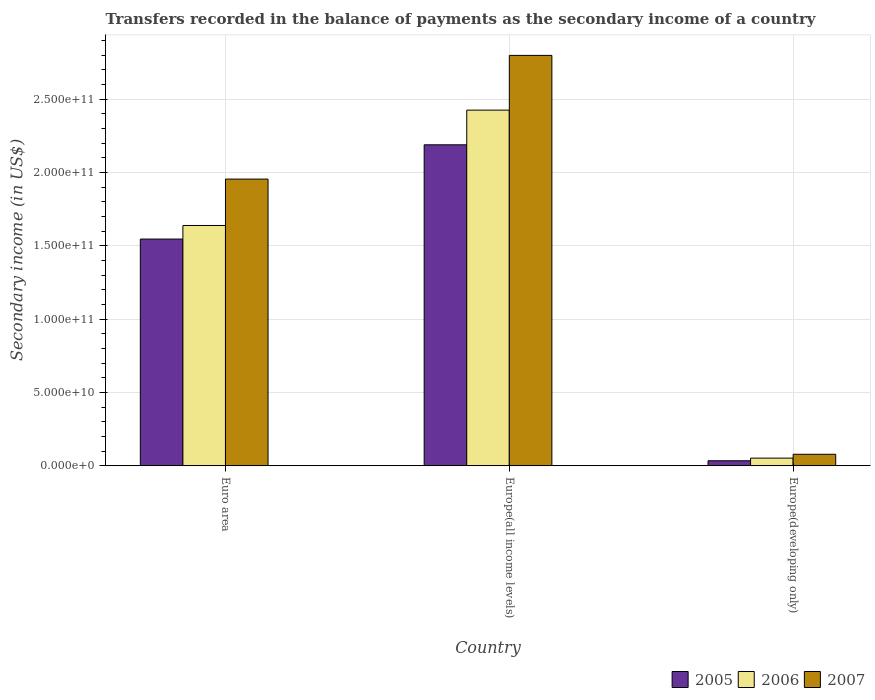How many different coloured bars are there?
Your answer should be very brief. 3. How many groups of bars are there?
Keep it short and to the point. 3. Are the number of bars per tick equal to the number of legend labels?
Provide a succinct answer. Yes. How many bars are there on the 2nd tick from the left?
Offer a very short reply. 3. What is the secondary income of in 2006 in Euro area?
Provide a short and direct response. 1.64e+11. Across all countries, what is the maximum secondary income of in 2005?
Your answer should be compact. 2.19e+11. Across all countries, what is the minimum secondary income of in 2007?
Provide a succinct answer. 7.81e+09. In which country was the secondary income of in 2005 maximum?
Ensure brevity in your answer.  Europe(all income levels). In which country was the secondary income of in 2006 minimum?
Make the answer very short. Europe(developing only). What is the total secondary income of in 2006 in the graph?
Your answer should be very brief. 4.11e+11. What is the difference between the secondary income of in 2005 in Euro area and that in Europe(all income levels)?
Make the answer very short. -6.43e+1. What is the difference between the secondary income of in 2005 in Euro area and the secondary income of in 2006 in Europe(all income levels)?
Your answer should be compact. -8.79e+1. What is the average secondary income of in 2007 per country?
Your answer should be very brief. 1.61e+11. What is the difference between the secondary income of of/in 2007 and secondary income of of/in 2005 in Europe(developing only)?
Offer a terse response. 4.43e+09. What is the ratio of the secondary income of in 2006 in Euro area to that in Europe(all income levels)?
Provide a short and direct response. 0.68. What is the difference between the highest and the second highest secondary income of in 2005?
Give a very brief answer. 1.51e+11. What is the difference between the highest and the lowest secondary income of in 2007?
Make the answer very short. 2.72e+11. How many bars are there?
Ensure brevity in your answer.  9. Are all the bars in the graph horizontal?
Your response must be concise. No. How many countries are there in the graph?
Your answer should be very brief. 3. What is the difference between two consecutive major ticks on the Y-axis?
Make the answer very short. 5.00e+1. Are the values on the major ticks of Y-axis written in scientific E-notation?
Provide a short and direct response. Yes. Does the graph contain any zero values?
Ensure brevity in your answer.  No. How many legend labels are there?
Your response must be concise. 3. How are the legend labels stacked?
Provide a short and direct response. Horizontal. What is the title of the graph?
Your answer should be very brief. Transfers recorded in the balance of payments as the secondary income of a country. Does "1963" appear as one of the legend labels in the graph?
Provide a succinct answer. No. What is the label or title of the Y-axis?
Make the answer very short. Secondary income (in US$). What is the Secondary income (in US$) of 2005 in Euro area?
Make the answer very short. 1.55e+11. What is the Secondary income (in US$) of 2006 in Euro area?
Ensure brevity in your answer.  1.64e+11. What is the Secondary income (in US$) of 2007 in Euro area?
Keep it short and to the point. 1.95e+11. What is the Secondary income (in US$) of 2005 in Europe(all income levels)?
Keep it short and to the point. 2.19e+11. What is the Secondary income (in US$) of 2006 in Europe(all income levels)?
Offer a terse response. 2.42e+11. What is the Secondary income (in US$) in 2007 in Europe(all income levels)?
Offer a terse response. 2.80e+11. What is the Secondary income (in US$) of 2005 in Europe(developing only)?
Give a very brief answer. 3.39e+09. What is the Secondary income (in US$) of 2006 in Europe(developing only)?
Your answer should be compact. 5.18e+09. What is the Secondary income (in US$) in 2007 in Europe(developing only)?
Offer a very short reply. 7.81e+09. Across all countries, what is the maximum Secondary income (in US$) of 2005?
Ensure brevity in your answer.  2.19e+11. Across all countries, what is the maximum Secondary income (in US$) in 2006?
Provide a succinct answer. 2.42e+11. Across all countries, what is the maximum Secondary income (in US$) in 2007?
Give a very brief answer. 2.80e+11. Across all countries, what is the minimum Secondary income (in US$) of 2005?
Offer a very short reply. 3.39e+09. Across all countries, what is the minimum Secondary income (in US$) of 2006?
Offer a very short reply. 5.18e+09. Across all countries, what is the minimum Secondary income (in US$) in 2007?
Make the answer very short. 7.81e+09. What is the total Secondary income (in US$) in 2005 in the graph?
Provide a short and direct response. 3.77e+11. What is the total Secondary income (in US$) of 2006 in the graph?
Make the answer very short. 4.11e+11. What is the total Secondary income (in US$) of 2007 in the graph?
Your answer should be very brief. 4.83e+11. What is the difference between the Secondary income (in US$) in 2005 in Euro area and that in Europe(all income levels)?
Provide a succinct answer. -6.43e+1. What is the difference between the Secondary income (in US$) of 2006 in Euro area and that in Europe(all income levels)?
Provide a succinct answer. -7.86e+1. What is the difference between the Secondary income (in US$) of 2007 in Euro area and that in Europe(all income levels)?
Your response must be concise. -8.43e+1. What is the difference between the Secondary income (in US$) of 2005 in Euro area and that in Europe(developing only)?
Offer a terse response. 1.51e+11. What is the difference between the Secondary income (in US$) in 2006 in Euro area and that in Europe(developing only)?
Keep it short and to the point. 1.59e+11. What is the difference between the Secondary income (in US$) in 2007 in Euro area and that in Europe(developing only)?
Provide a short and direct response. 1.88e+11. What is the difference between the Secondary income (in US$) of 2005 in Europe(all income levels) and that in Europe(developing only)?
Offer a very short reply. 2.15e+11. What is the difference between the Secondary income (in US$) in 2006 in Europe(all income levels) and that in Europe(developing only)?
Give a very brief answer. 2.37e+11. What is the difference between the Secondary income (in US$) in 2007 in Europe(all income levels) and that in Europe(developing only)?
Offer a very short reply. 2.72e+11. What is the difference between the Secondary income (in US$) in 2005 in Euro area and the Secondary income (in US$) in 2006 in Europe(all income levels)?
Provide a short and direct response. -8.79e+1. What is the difference between the Secondary income (in US$) of 2005 in Euro area and the Secondary income (in US$) of 2007 in Europe(all income levels)?
Your answer should be compact. -1.25e+11. What is the difference between the Secondary income (in US$) in 2006 in Euro area and the Secondary income (in US$) in 2007 in Europe(all income levels)?
Ensure brevity in your answer.  -1.16e+11. What is the difference between the Secondary income (in US$) of 2005 in Euro area and the Secondary income (in US$) of 2006 in Europe(developing only)?
Make the answer very short. 1.49e+11. What is the difference between the Secondary income (in US$) in 2005 in Euro area and the Secondary income (in US$) in 2007 in Europe(developing only)?
Your response must be concise. 1.47e+11. What is the difference between the Secondary income (in US$) in 2006 in Euro area and the Secondary income (in US$) in 2007 in Europe(developing only)?
Your answer should be very brief. 1.56e+11. What is the difference between the Secondary income (in US$) of 2005 in Europe(all income levels) and the Secondary income (in US$) of 2006 in Europe(developing only)?
Ensure brevity in your answer.  2.14e+11. What is the difference between the Secondary income (in US$) in 2005 in Europe(all income levels) and the Secondary income (in US$) in 2007 in Europe(developing only)?
Keep it short and to the point. 2.11e+11. What is the difference between the Secondary income (in US$) of 2006 in Europe(all income levels) and the Secondary income (in US$) of 2007 in Europe(developing only)?
Provide a short and direct response. 2.35e+11. What is the average Secondary income (in US$) in 2005 per country?
Make the answer very short. 1.26e+11. What is the average Secondary income (in US$) in 2006 per country?
Ensure brevity in your answer.  1.37e+11. What is the average Secondary income (in US$) of 2007 per country?
Offer a terse response. 1.61e+11. What is the difference between the Secondary income (in US$) in 2005 and Secondary income (in US$) in 2006 in Euro area?
Keep it short and to the point. -9.25e+09. What is the difference between the Secondary income (in US$) of 2005 and Secondary income (in US$) of 2007 in Euro area?
Offer a terse response. -4.09e+1. What is the difference between the Secondary income (in US$) of 2006 and Secondary income (in US$) of 2007 in Euro area?
Your answer should be compact. -3.16e+1. What is the difference between the Secondary income (in US$) of 2005 and Secondary income (in US$) of 2006 in Europe(all income levels)?
Your answer should be compact. -2.36e+1. What is the difference between the Secondary income (in US$) in 2005 and Secondary income (in US$) in 2007 in Europe(all income levels)?
Ensure brevity in your answer.  -6.10e+1. What is the difference between the Secondary income (in US$) of 2006 and Secondary income (in US$) of 2007 in Europe(all income levels)?
Provide a succinct answer. -3.73e+1. What is the difference between the Secondary income (in US$) in 2005 and Secondary income (in US$) in 2006 in Europe(developing only)?
Offer a very short reply. -1.80e+09. What is the difference between the Secondary income (in US$) in 2005 and Secondary income (in US$) in 2007 in Europe(developing only)?
Your response must be concise. -4.43e+09. What is the difference between the Secondary income (in US$) in 2006 and Secondary income (in US$) in 2007 in Europe(developing only)?
Provide a succinct answer. -2.63e+09. What is the ratio of the Secondary income (in US$) in 2005 in Euro area to that in Europe(all income levels)?
Your answer should be very brief. 0.71. What is the ratio of the Secondary income (in US$) in 2006 in Euro area to that in Europe(all income levels)?
Offer a terse response. 0.68. What is the ratio of the Secondary income (in US$) of 2007 in Euro area to that in Europe(all income levels)?
Your response must be concise. 0.7. What is the ratio of the Secondary income (in US$) of 2005 in Euro area to that in Europe(developing only)?
Your answer should be very brief. 45.64. What is the ratio of the Secondary income (in US$) of 2006 in Euro area to that in Europe(developing only)?
Provide a succinct answer. 31.6. What is the ratio of the Secondary income (in US$) in 2007 in Euro area to that in Europe(developing only)?
Ensure brevity in your answer.  25.02. What is the ratio of the Secondary income (in US$) of 2005 in Europe(all income levels) to that in Europe(developing only)?
Give a very brief answer. 64.61. What is the ratio of the Secondary income (in US$) of 2006 in Europe(all income levels) to that in Europe(developing only)?
Your answer should be very brief. 46.77. What is the ratio of the Secondary income (in US$) in 2007 in Europe(all income levels) to that in Europe(developing only)?
Your response must be concise. 35.81. What is the difference between the highest and the second highest Secondary income (in US$) in 2005?
Keep it short and to the point. 6.43e+1. What is the difference between the highest and the second highest Secondary income (in US$) of 2006?
Offer a terse response. 7.86e+1. What is the difference between the highest and the second highest Secondary income (in US$) of 2007?
Give a very brief answer. 8.43e+1. What is the difference between the highest and the lowest Secondary income (in US$) in 2005?
Provide a succinct answer. 2.15e+11. What is the difference between the highest and the lowest Secondary income (in US$) in 2006?
Ensure brevity in your answer.  2.37e+11. What is the difference between the highest and the lowest Secondary income (in US$) in 2007?
Make the answer very short. 2.72e+11. 